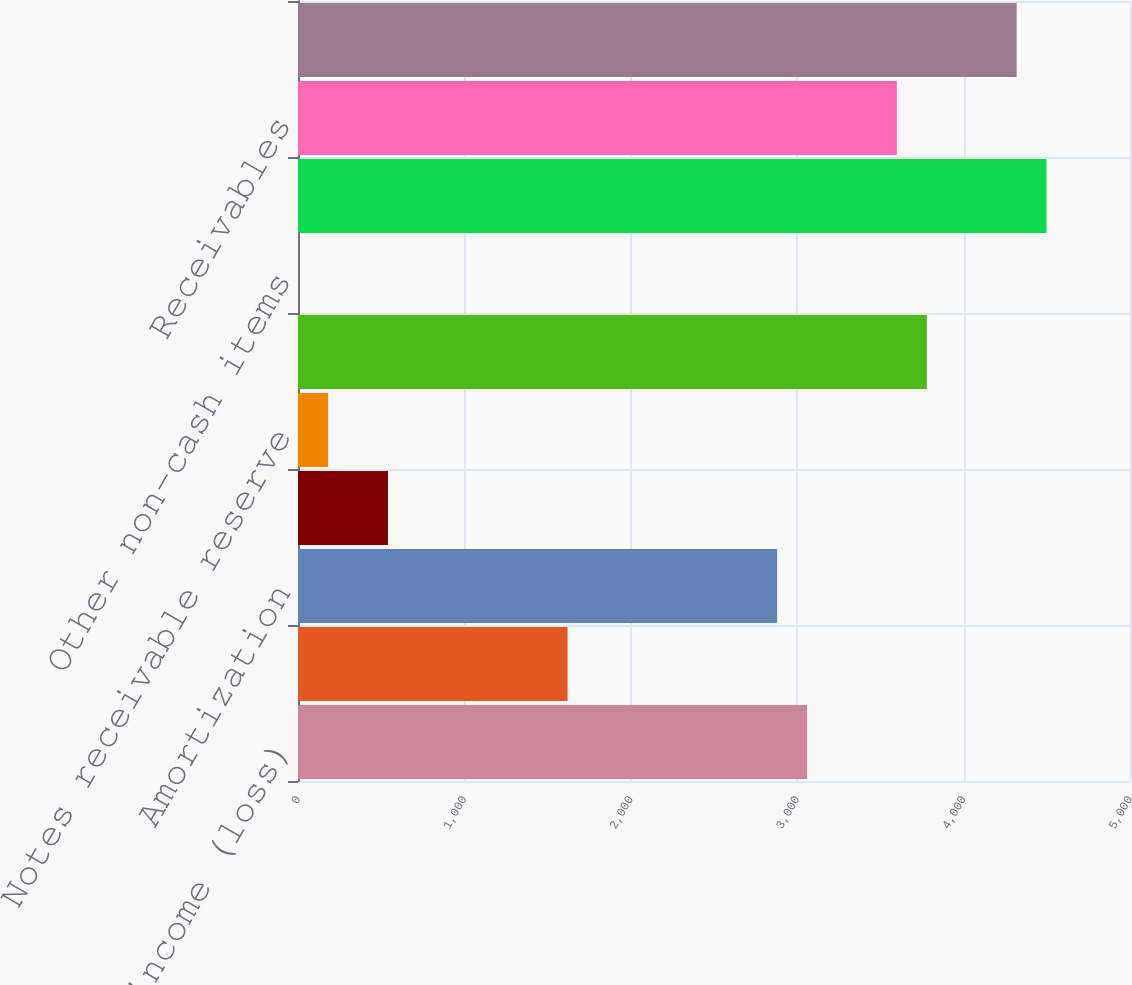Convert chart. <chart><loc_0><loc_0><loc_500><loc_500><bar_chart><fcel>Net income (loss)<fcel>Depreciation<fcel>Amortization<fcel>Provision for bad debts<fcel>Notes receivable reserve<fcel>Deferred taxes<fcel>Other non-cash items<fcel>Total<fcel>Receivables<fcel>Inventories<nl><fcel>3059.3<fcel>1620.1<fcel>2879.4<fcel>540.7<fcel>180.9<fcel>3778.9<fcel>1<fcel>4498.5<fcel>3599<fcel>4318.6<nl></chart> 